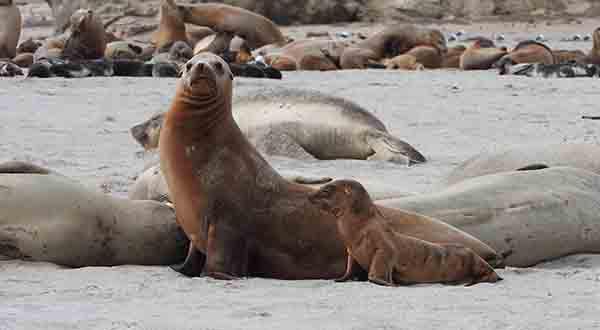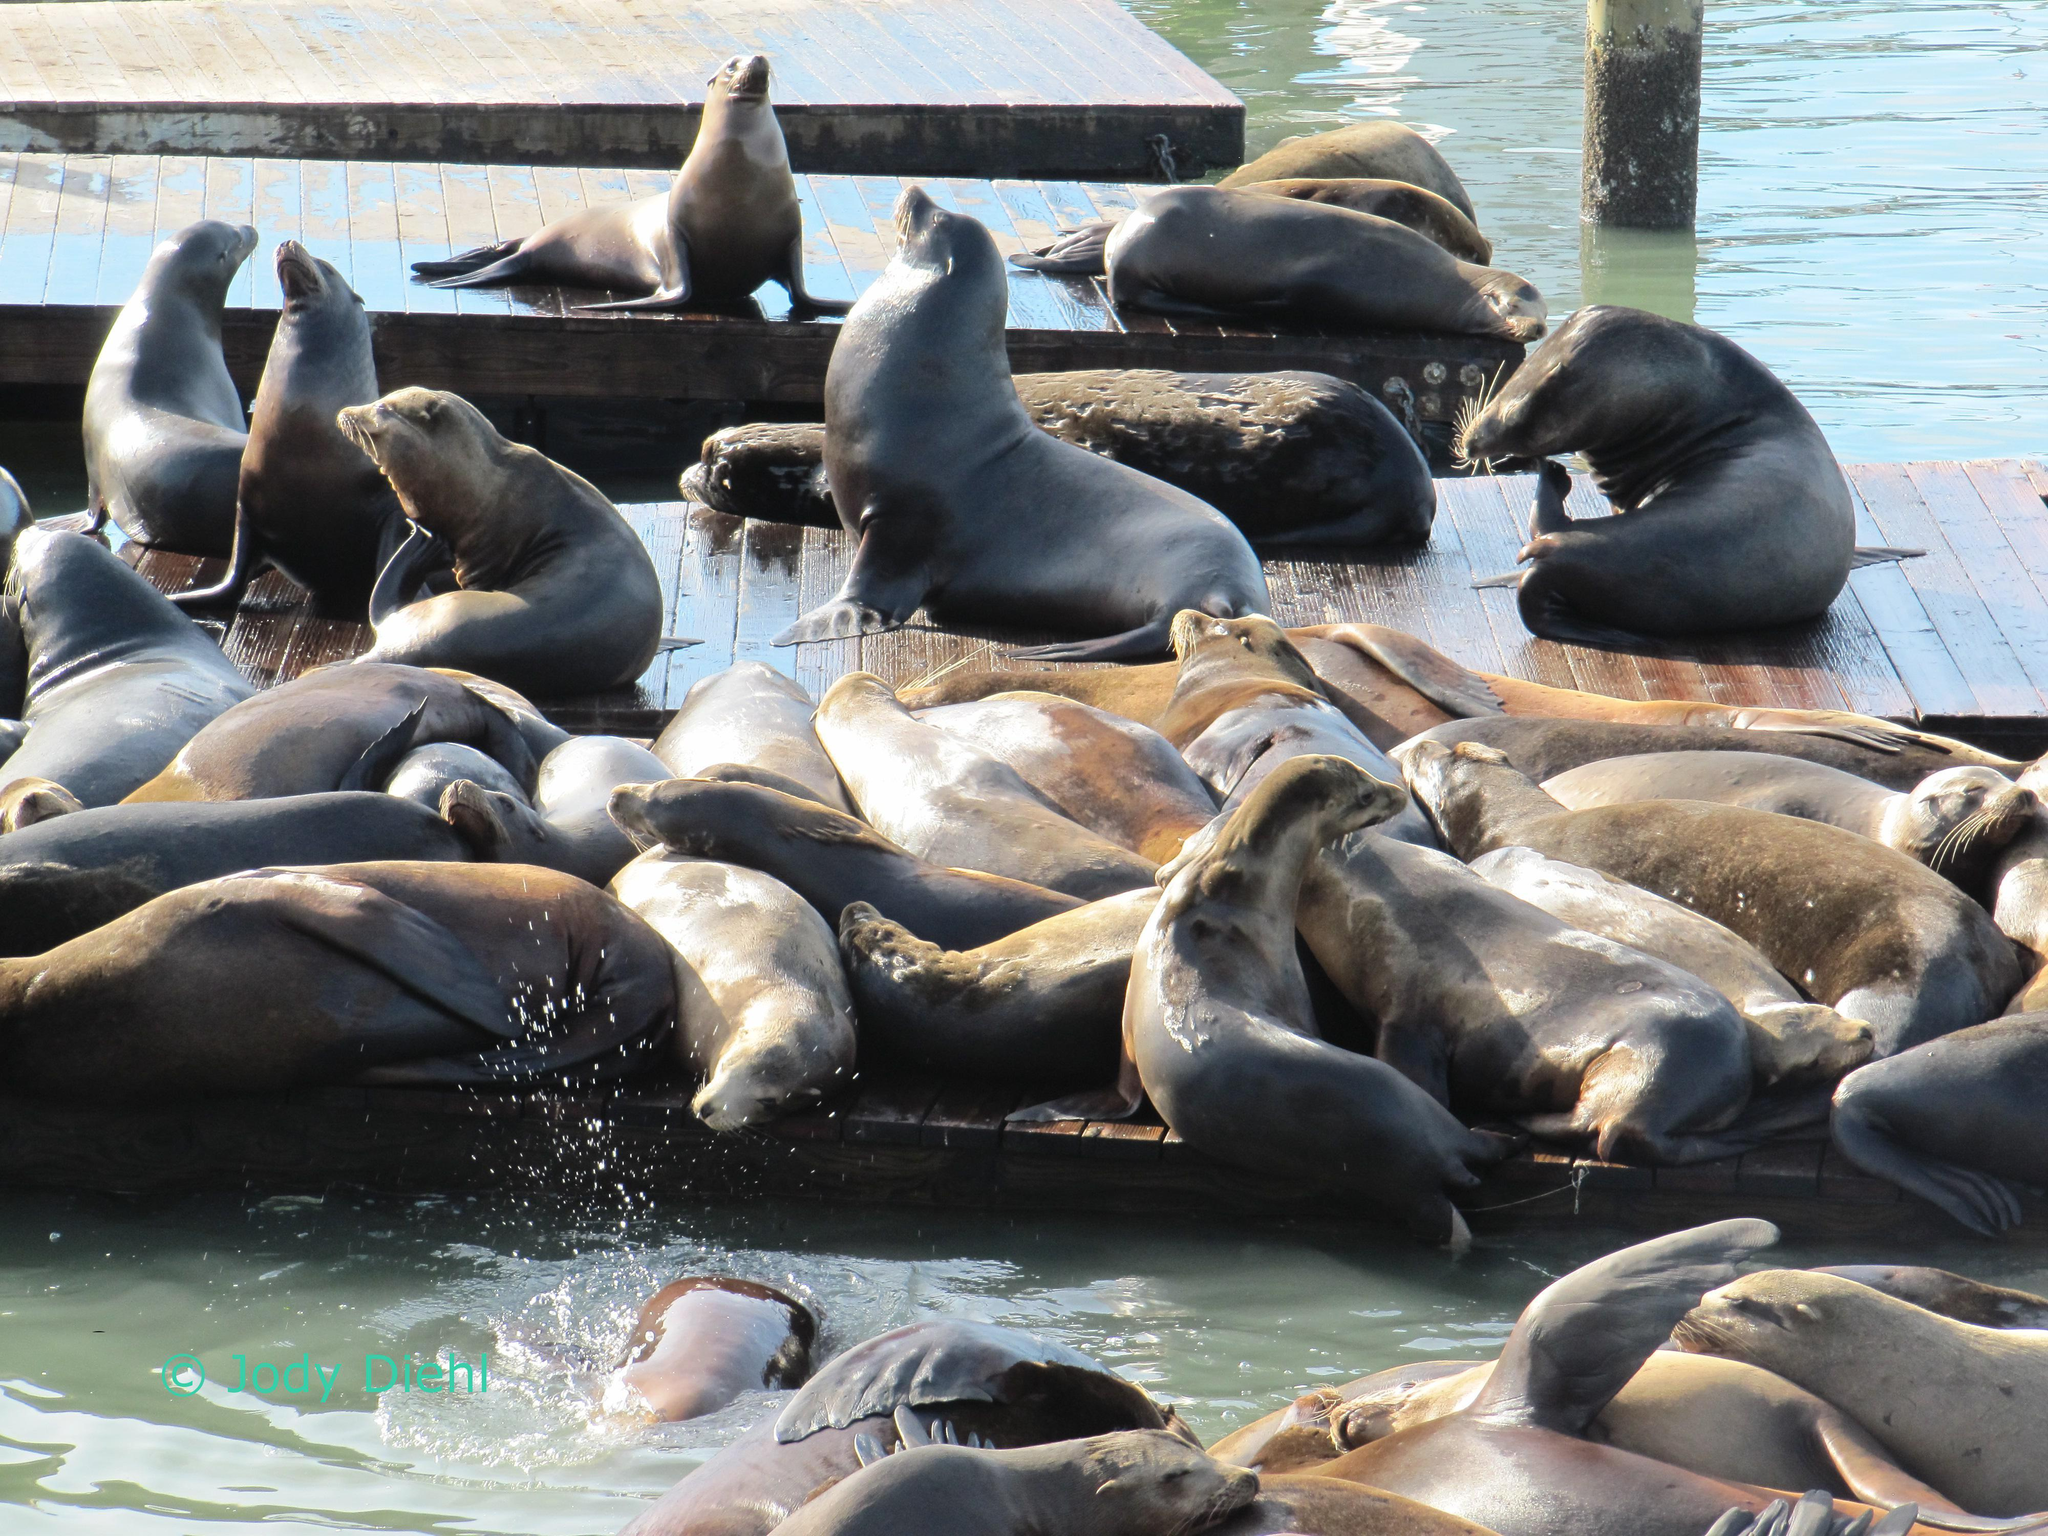The first image is the image on the left, the second image is the image on the right. Examine the images to the left and right. Is the description "One image shows white spray from waves crashing where seals are gathered, and the other shows a mass of seals with no ocean background." accurate? Answer yes or no. No. 